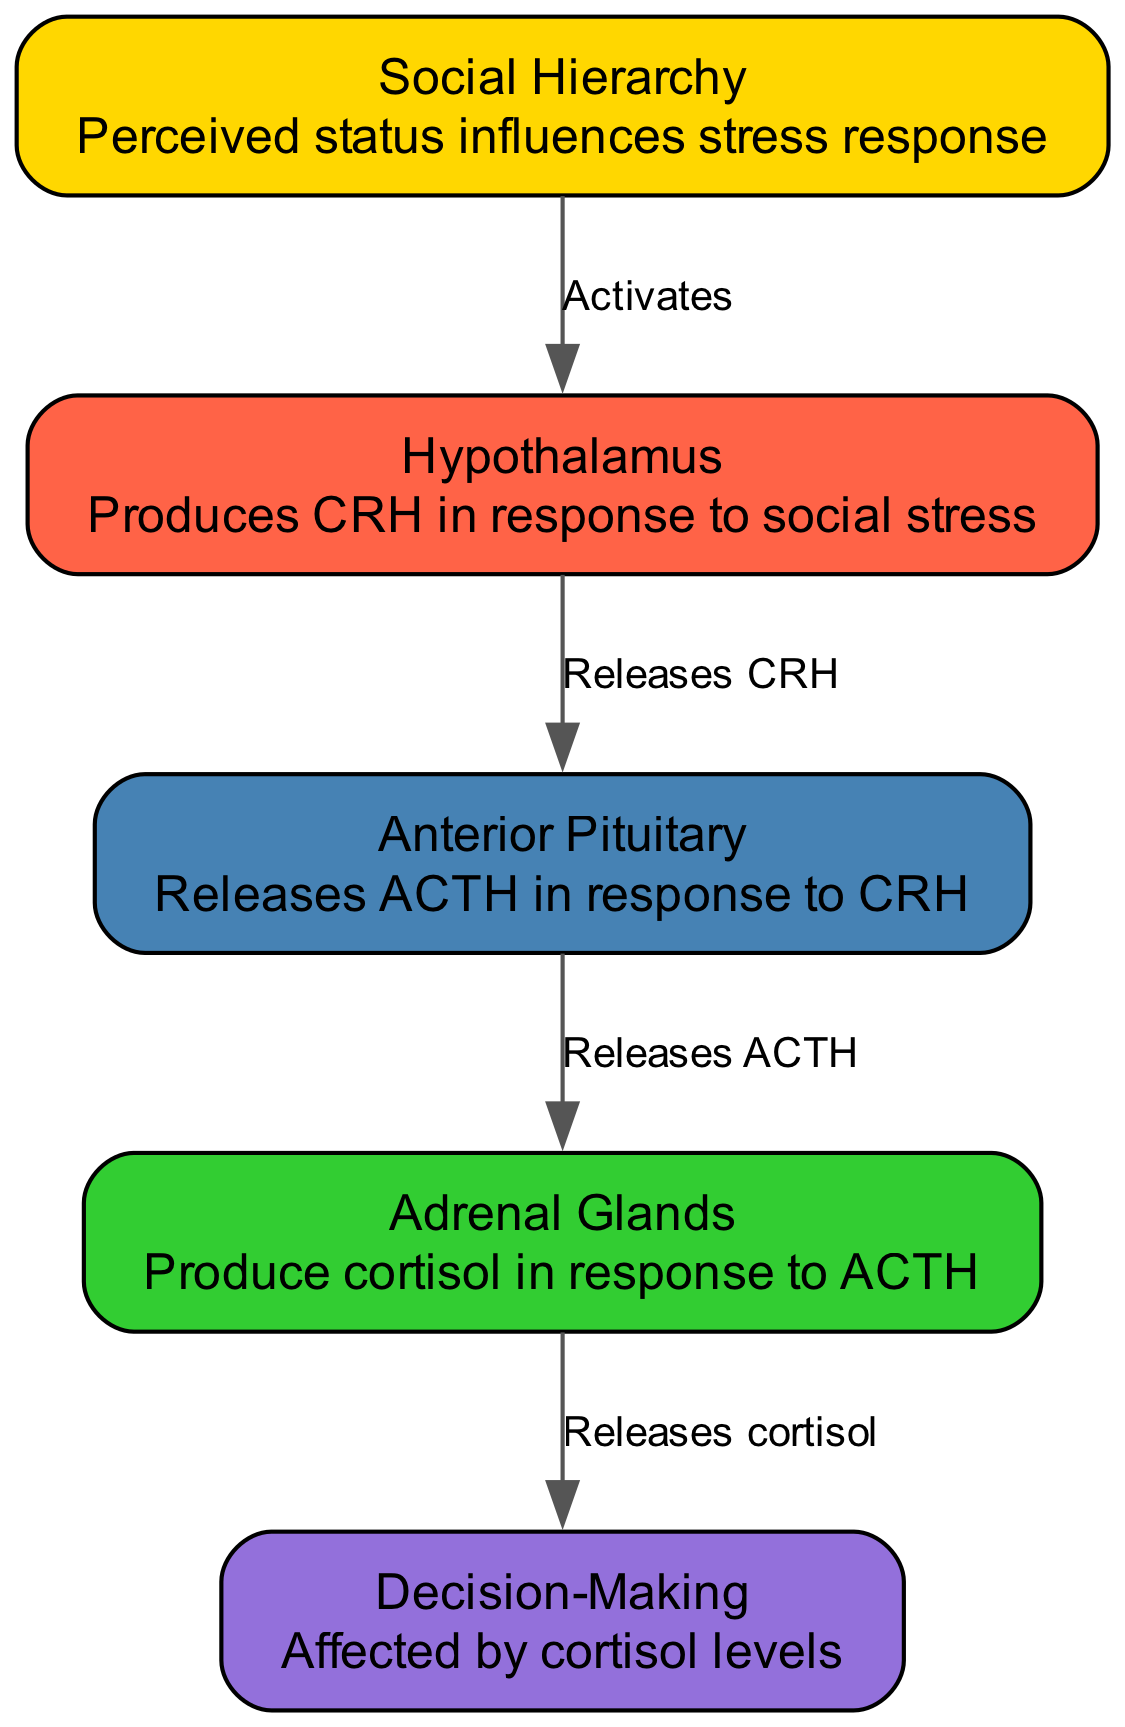What is released by the hypothalamus in response to social stress? According to the diagram, the hypothalamus produces CRH (Corticotropin-Releasing Hormone) when it receives signals from the social hierarchy, which is labeled as "Activates" in the edge connecting the social hierarchy node to the hypothalamus node.
Answer: CRH Which gland produces cortisol? The diagram indicates that the adrenal glands are responsible for producing cortisol, as shown by the edge labeled "Releases cortisol" from the adrenal node to the decision-making node.
Answer: Adrenal Glands How many nodes are in the diagram? By counting the nodes listed in the diagram data, there are a total of five nodes: hypothalamus, anterior pituitary, adrenal glands, social hierarchy, and decision-making.
Answer: 5 What is the relationship between the pituitary and adrenal glands? The relationship is represented by the edge labeled "Releases ACTH," which indicates that the anterior pituitary releases ACTH (Adrenocorticotropic Hormone) in response to CRH produced by the hypothalamus.
Answer: Releases ACTH What role does perceived status play in the HPA axis? The social hierarchy node is indicated to activate the hypothalamus, meaning that perceived status influences the hypothalamus to produce CRH, which subsequently affects the entire HPA axis in stress response.
Answer: Activates hypothalamus How does cortisol affect decision-making? The diagram shows that cortisol is released by the adrenal glands and it directly influences the decision-making process, indicated by the edge labeled "Releases cortisol" leading to the decision-making node.
Answer: Affected by cortisol levels Which node produces ACTH? According to the provided data, the anterior pituitary is responsible for releasing ACTH, as specified in the relationship from the pituitary node to the adrenal node.
Answer: Anterior Pituitary What do the arrows in the diagram represent? The arrows in the diagram represent relationships between different components of the HPA axis, where each arrow indicates the activation or release of hormones or signals from one node to another.
Answer: Relationships 